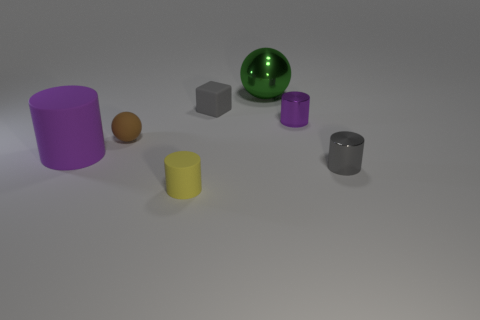Subtract all tiny rubber cylinders. How many cylinders are left? 3 Subtract all green balls. How many balls are left? 1 Subtract all cylinders. How many objects are left? 3 Add 3 small yellow rubber cylinders. How many objects exist? 10 Subtract all gray metallic objects. Subtract all small yellow objects. How many objects are left? 5 Add 6 purple cylinders. How many purple cylinders are left? 8 Add 6 big brown metallic blocks. How many big brown metallic blocks exist? 6 Subtract 0 purple balls. How many objects are left? 7 Subtract 1 cubes. How many cubes are left? 0 Subtract all red blocks. Subtract all cyan cylinders. How many blocks are left? 1 